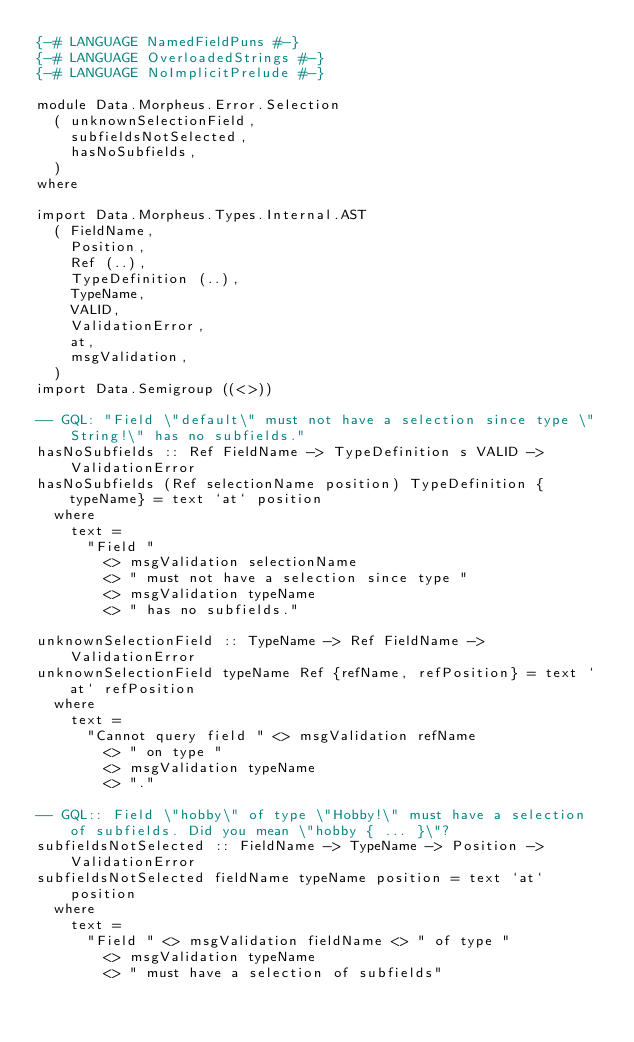<code> <loc_0><loc_0><loc_500><loc_500><_Haskell_>{-# LANGUAGE NamedFieldPuns #-}
{-# LANGUAGE OverloadedStrings #-}
{-# LANGUAGE NoImplicitPrelude #-}

module Data.Morpheus.Error.Selection
  ( unknownSelectionField,
    subfieldsNotSelected,
    hasNoSubfields,
  )
where

import Data.Morpheus.Types.Internal.AST
  ( FieldName,
    Position,
    Ref (..),
    TypeDefinition (..),
    TypeName,
    VALID,
    ValidationError,
    at,
    msgValidation,
  )
import Data.Semigroup ((<>))

-- GQL: "Field \"default\" must not have a selection since type \"String!\" has no subfields."
hasNoSubfields :: Ref FieldName -> TypeDefinition s VALID -> ValidationError
hasNoSubfields (Ref selectionName position) TypeDefinition {typeName} = text `at` position
  where
    text =
      "Field "
        <> msgValidation selectionName
        <> " must not have a selection since type "
        <> msgValidation typeName
        <> " has no subfields."

unknownSelectionField :: TypeName -> Ref FieldName -> ValidationError
unknownSelectionField typeName Ref {refName, refPosition} = text `at` refPosition
  where
    text =
      "Cannot query field " <> msgValidation refName
        <> " on type "
        <> msgValidation typeName
        <> "."

-- GQL:: Field \"hobby\" of type \"Hobby!\" must have a selection of subfields. Did you mean \"hobby { ... }\"?
subfieldsNotSelected :: FieldName -> TypeName -> Position -> ValidationError
subfieldsNotSelected fieldName typeName position = text `at` position
  where
    text =
      "Field " <> msgValidation fieldName <> " of type "
        <> msgValidation typeName
        <> " must have a selection of subfields"
</code> 